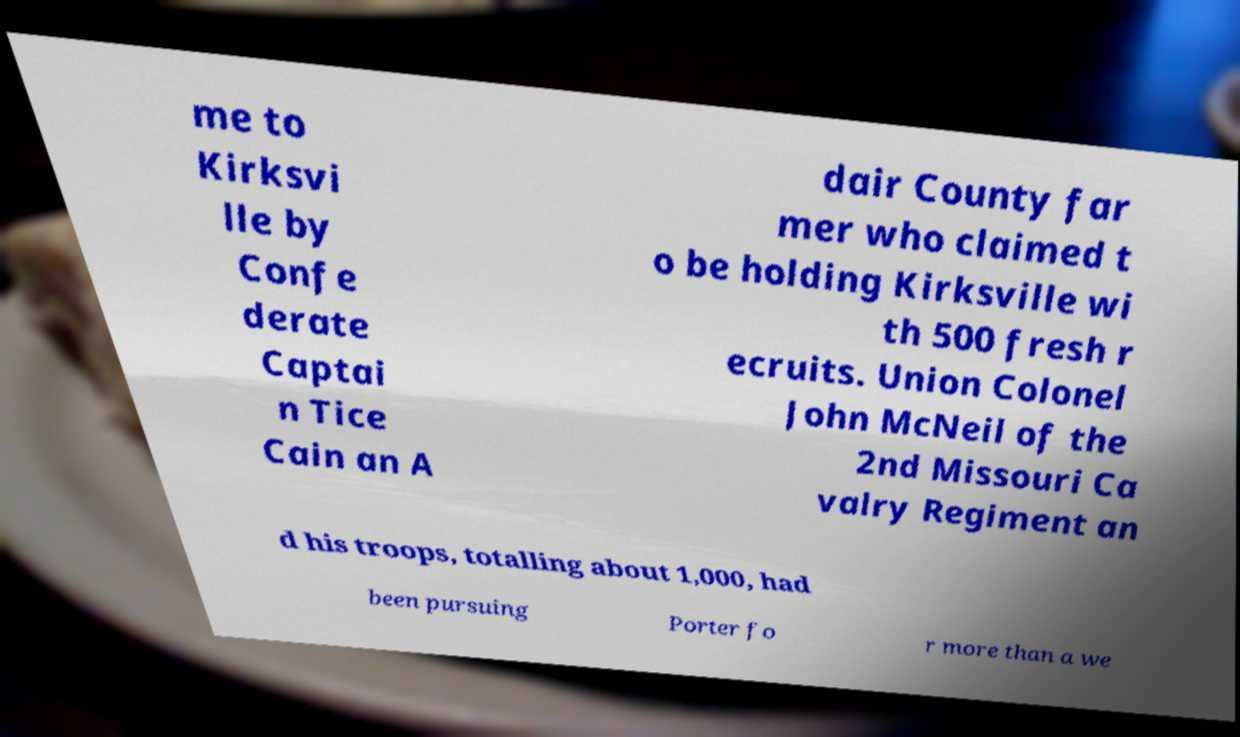For documentation purposes, I need the text within this image transcribed. Could you provide that? me to Kirksvi lle by Confe derate Captai n Tice Cain an A dair County far mer who claimed t o be holding Kirksville wi th 500 fresh r ecruits. Union Colonel John McNeil of the 2nd Missouri Ca valry Regiment an d his troops, totalling about 1,000, had been pursuing Porter fo r more than a we 